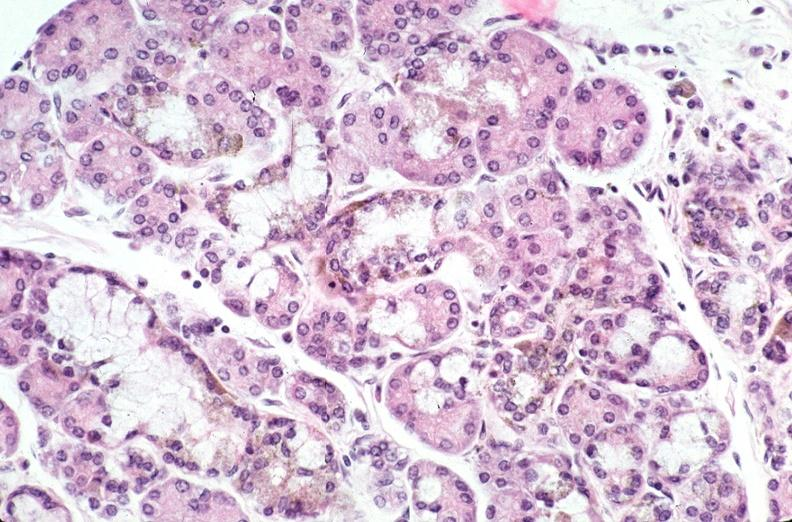does bone, clivus show pancreas, hemochromatosis?
Answer the question using a single word or phrase. No 